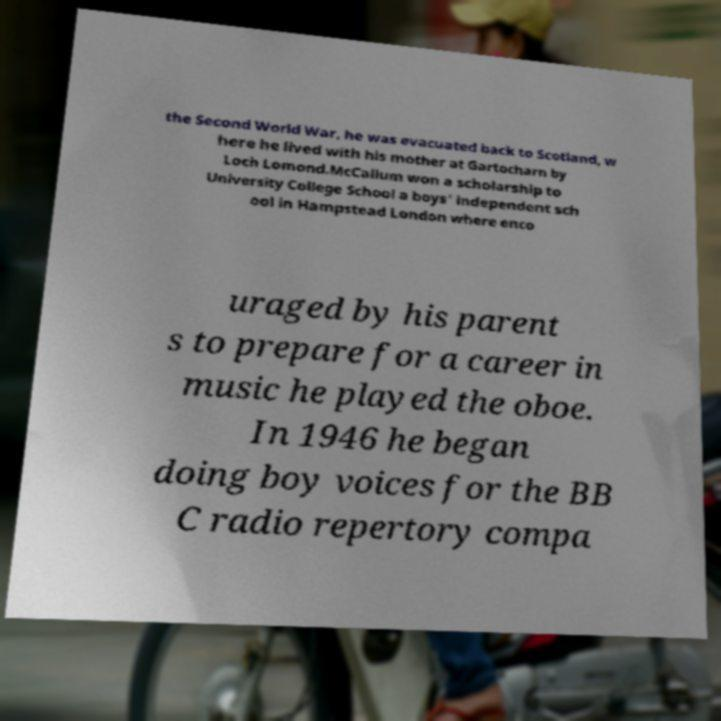I need the written content from this picture converted into text. Can you do that? the Second World War, he was evacuated back to Scotland, w here he lived with his mother at Gartocharn by Loch Lomond.McCallum won a scholarship to University College School a boys' independent sch ool in Hampstead London where enco uraged by his parent s to prepare for a career in music he played the oboe. In 1946 he began doing boy voices for the BB C radio repertory compa 